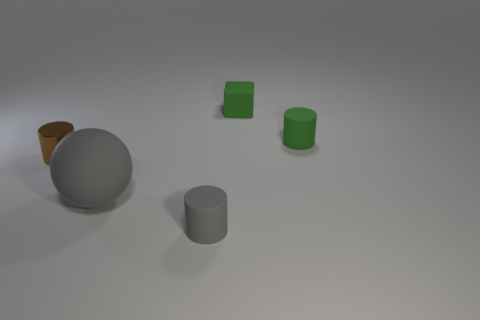Are any purple things visible?
Ensure brevity in your answer.  No. There is a tiny object that is behind the green cylinder; what is its shape?
Ensure brevity in your answer.  Cube. How many tiny matte cylinders are left of the small block and on the right side of the tiny green cube?
Make the answer very short. 0. What number of other things are there of the same size as the brown thing?
Provide a succinct answer. 3. There is a small thing left of the gray cylinder; is it the same shape as the small rubber thing in front of the small brown metallic object?
Ensure brevity in your answer.  Yes. What number of objects are either metallic cylinders or gray objects in front of the gray rubber ball?
Your answer should be compact. 2. What is the material of the cylinder that is to the left of the green cube and behind the large matte thing?
Make the answer very short. Metal. Is there anything else that has the same shape as the small brown metallic thing?
Offer a very short reply. Yes. The sphere that is made of the same material as the cube is what color?
Provide a short and direct response. Gray. How many things are either gray balls or large brown metallic cylinders?
Offer a very short reply. 1. 